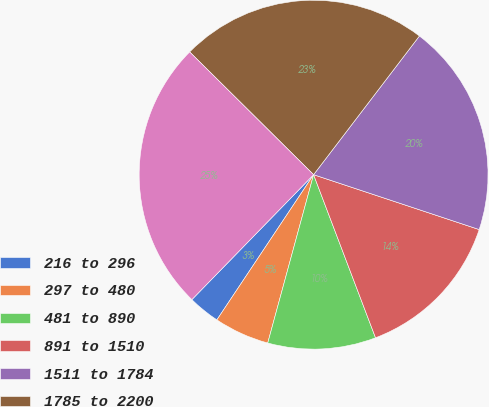Convert chart. <chart><loc_0><loc_0><loc_500><loc_500><pie_chart><fcel>216 to 296<fcel>297 to 480<fcel>481 to 890<fcel>891 to 1510<fcel>1511 to 1784<fcel>1785 to 2200<fcel>2201 to 3491<nl><fcel>2.94%<fcel>5.12%<fcel>10.01%<fcel>14.13%<fcel>19.72%<fcel>22.95%<fcel>25.13%<nl></chart> 